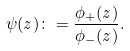Convert formula to latex. <formula><loc_0><loc_0><loc_500><loc_500>\psi ( z ) \colon = \frac { \phi _ { + } ( z ) } { \phi _ { - } ( z ) } .</formula> 